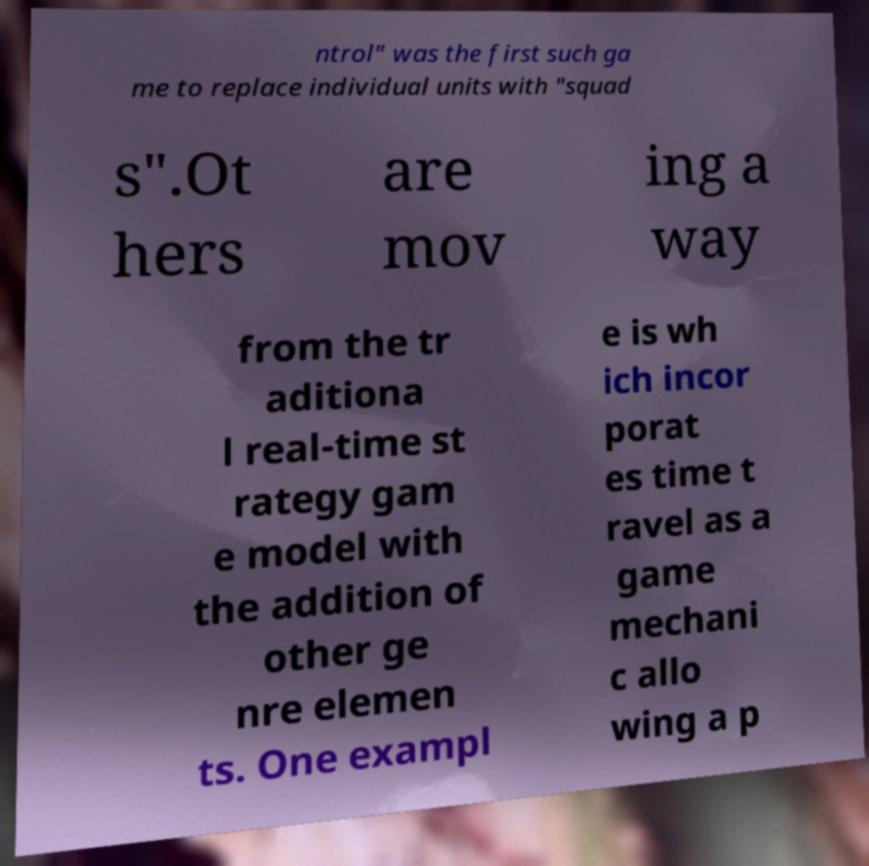Could you extract and type out the text from this image? ntrol" was the first such ga me to replace individual units with "squad s".Ot hers are mov ing a way from the tr aditiona l real-time st rategy gam e model with the addition of other ge nre elemen ts. One exampl e is wh ich incor porat es time t ravel as a game mechani c allo wing a p 